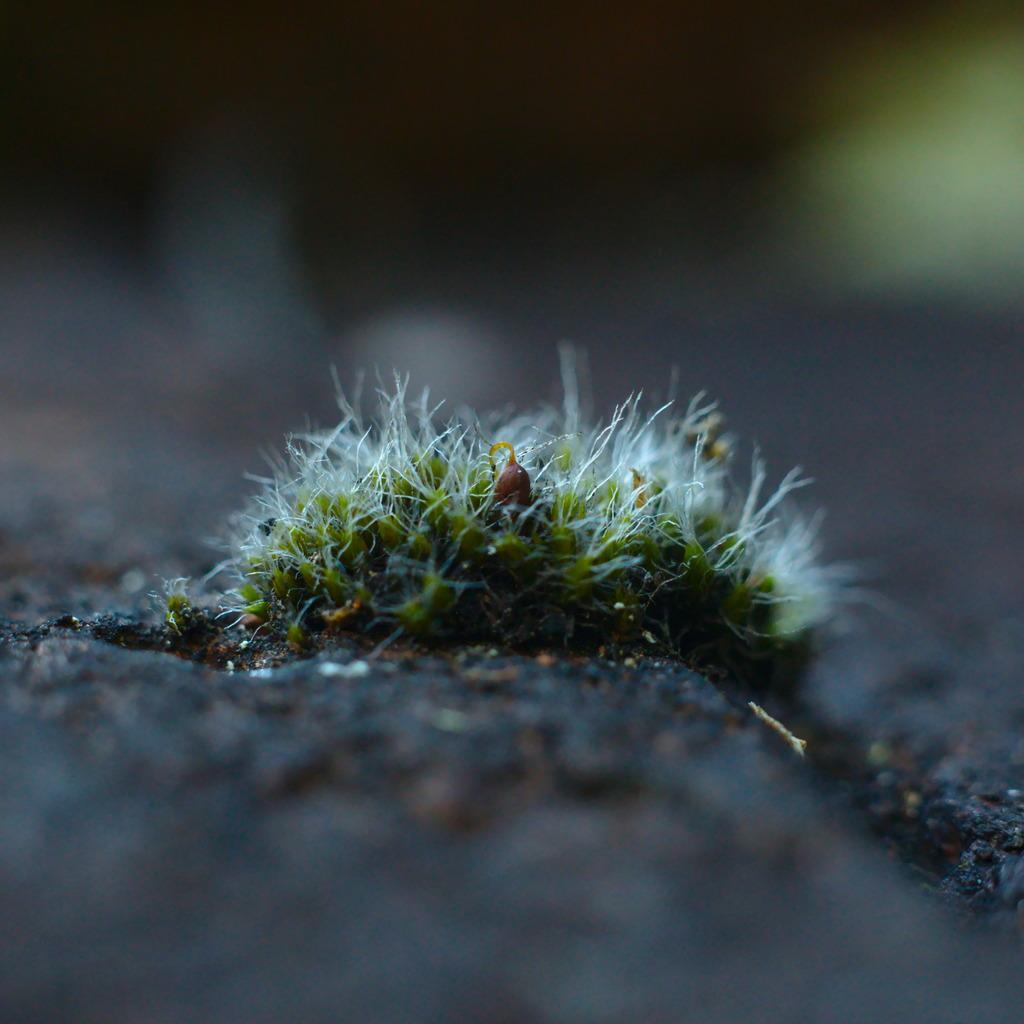In one or two sentences, can you explain what this image depicts? In this image I can see grass in green color and I can see blurred background. 